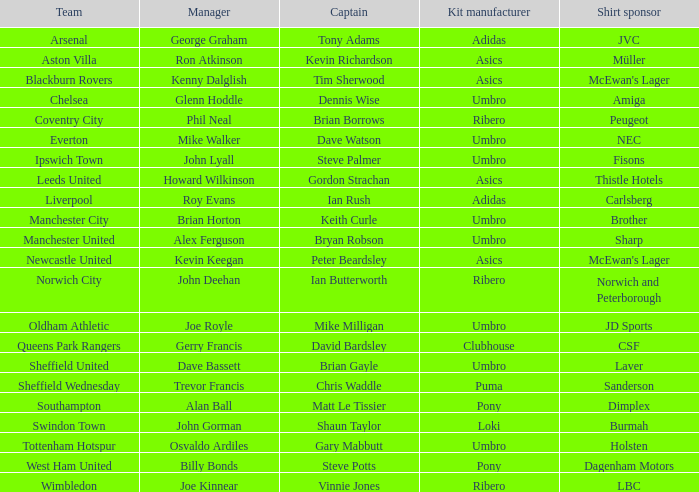Which team has george graham as the manager? Arsenal. 